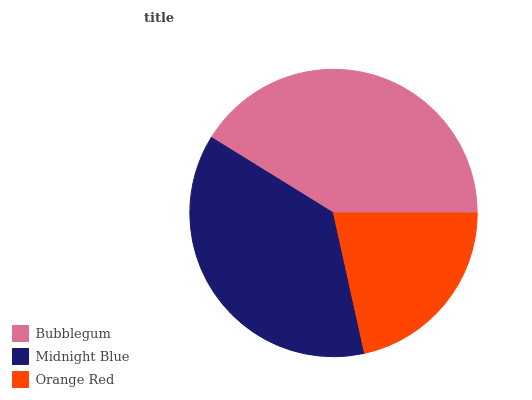Is Orange Red the minimum?
Answer yes or no. Yes. Is Bubblegum the maximum?
Answer yes or no. Yes. Is Midnight Blue the minimum?
Answer yes or no. No. Is Midnight Blue the maximum?
Answer yes or no. No. Is Bubblegum greater than Midnight Blue?
Answer yes or no. Yes. Is Midnight Blue less than Bubblegum?
Answer yes or no. Yes. Is Midnight Blue greater than Bubblegum?
Answer yes or no. No. Is Bubblegum less than Midnight Blue?
Answer yes or no. No. Is Midnight Blue the high median?
Answer yes or no. Yes. Is Midnight Blue the low median?
Answer yes or no. Yes. Is Orange Red the high median?
Answer yes or no. No. Is Bubblegum the low median?
Answer yes or no. No. 